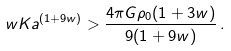Convert formula to latex. <formula><loc_0><loc_0><loc_500><loc_500>w K a ^ { ( 1 + 9 w ) } > \frac { 4 \pi G \rho _ { 0 } ( 1 + 3 w ) } { 9 ( 1 + 9 w ) } \, .</formula> 